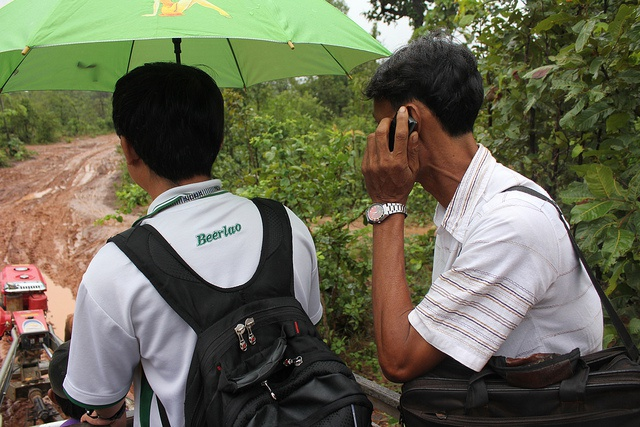Describe the objects in this image and their specific colors. I can see people in white, black, lightgray, darkgray, and gray tones, people in white, lightgray, black, darkgray, and maroon tones, umbrella in white, lightgreen, olive, green, and khaki tones, backpack in white, black, gray, darkgray, and purple tones, and handbag in white, black, gray, maroon, and darkgreen tones in this image. 